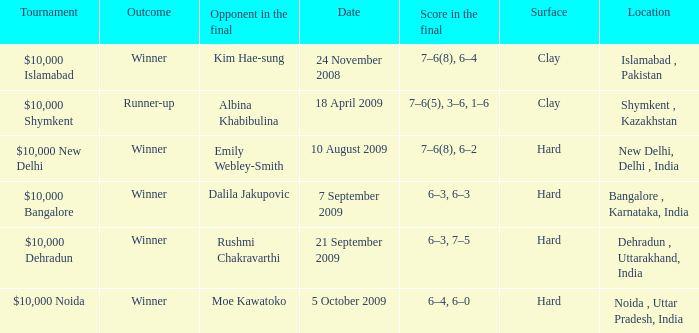What is the material of the surface in the dehradun , uttarakhand, india location Hard. 